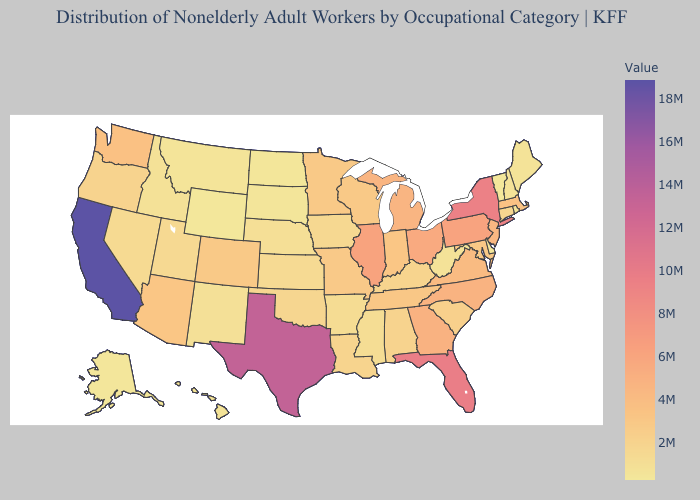Does Wyoming have the lowest value in the USA?
Keep it brief. Yes. Among the states that border Louisiana , which have the lowest value?
Concise answer only. Mississippi. Among the states that border South Carolina , which have the highest value?
Quick response, please. Georgia. Which states have the lowest value in the Northeast?
Be succinct. Vermont. Does the map have missing data?
Write a very short answer. No. Which states have the highest value in the USA?
Write a very short answer. California. Among the states that border New York , does Vermont have the lowest value?
Give a very brief answer. Yes. Does the map have missing data?
Quick response, please. No. 